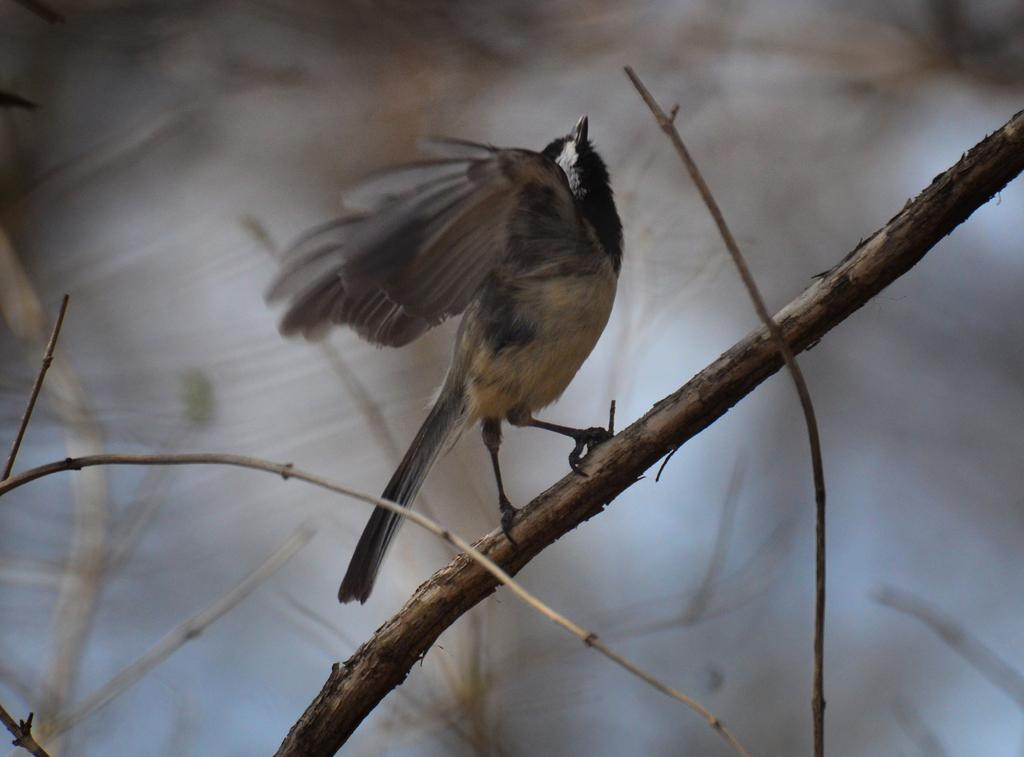What type of animal is in the image? There is a bird in the image. Where is the bird located? The bird is on a branch. Can you describe the background of the image? The background of the image is blurred. Can you tell me how many goats are visible in the image? There are no goats present in the image; it features a bird on a branch. What type of cub is visible in the image? There is no cub present in the image. 